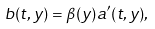<formula> <loc_0><loc_0><loc_500><loc_500>b ( t , y ) = \beta ( y ) a ^ { \prime } ( t , y ) ,</formula> 